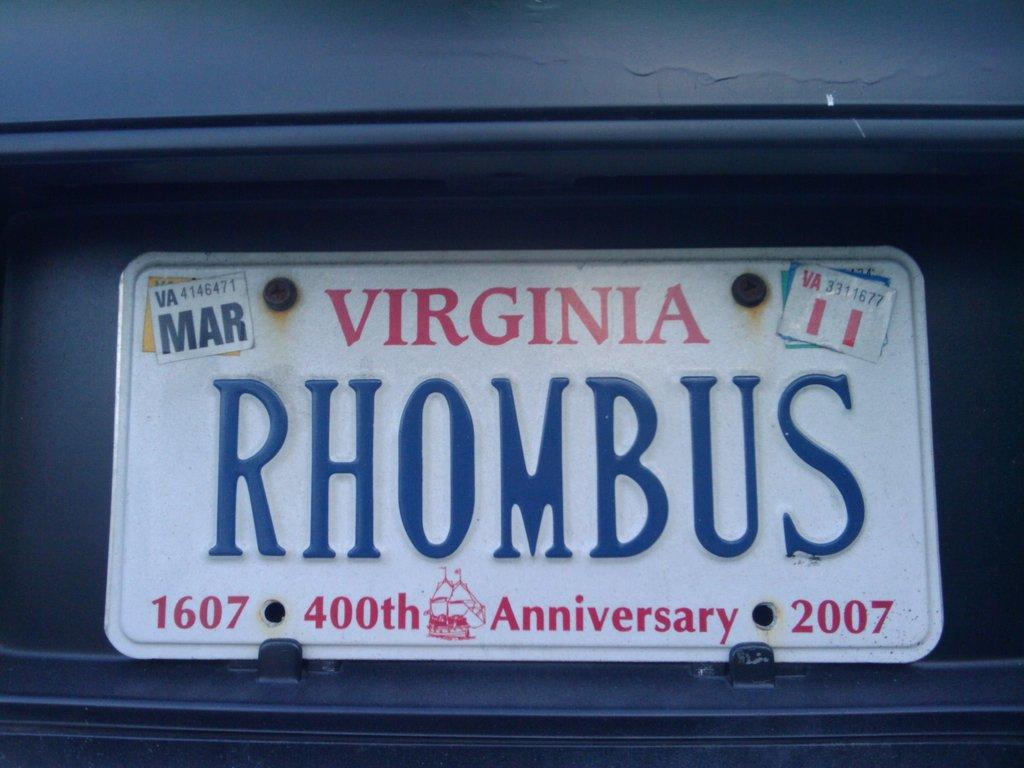What is the main subject in the center of the image? There is a name board in the center of the image. What can be found on the name board? There is text on the name board. Can you describe anything visible in the background of the image? There is an object visible in the background of the image. What type of operation is being performed on the name board in the image? There is no operation being performed on the name board in the image; it is simply displaying text. Can you tell me where the middle of the name board is located in the image? The concept of a "middle" of the name board is not relevant in this context, as it is a flat object with text. 